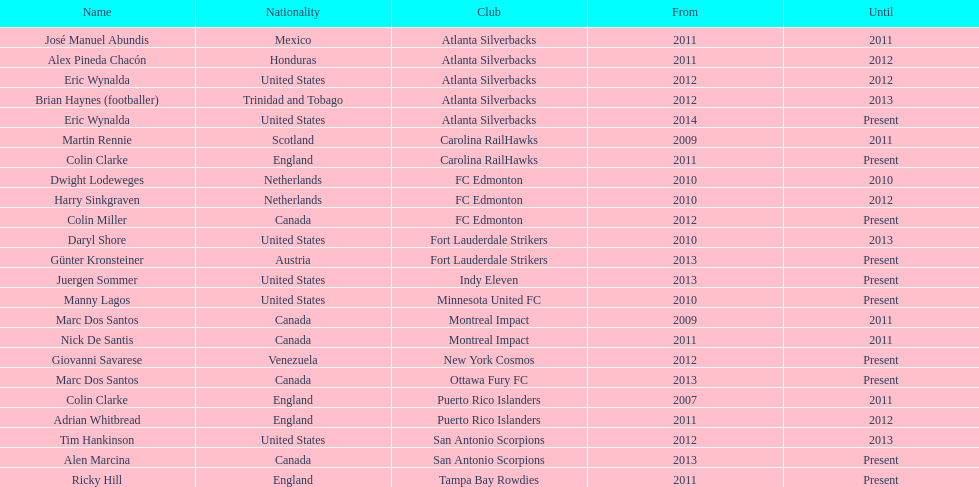How long did colin clarke coach the puerto rico islanders? 4 years. 